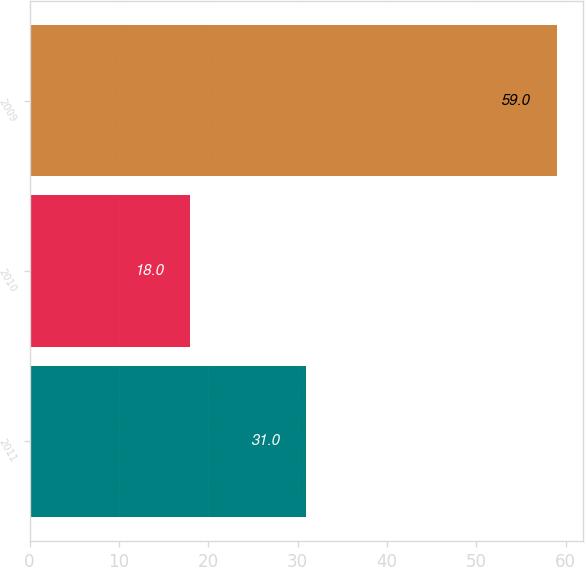Convert chart to OTSL. <chart><loc_0><loc_0><loc_500><loc_500><bar_chart><fcel>2011<fcel>2010<fcel>2009<nl><fcel>31<fcel>18<fcel>59<nl></chart> 